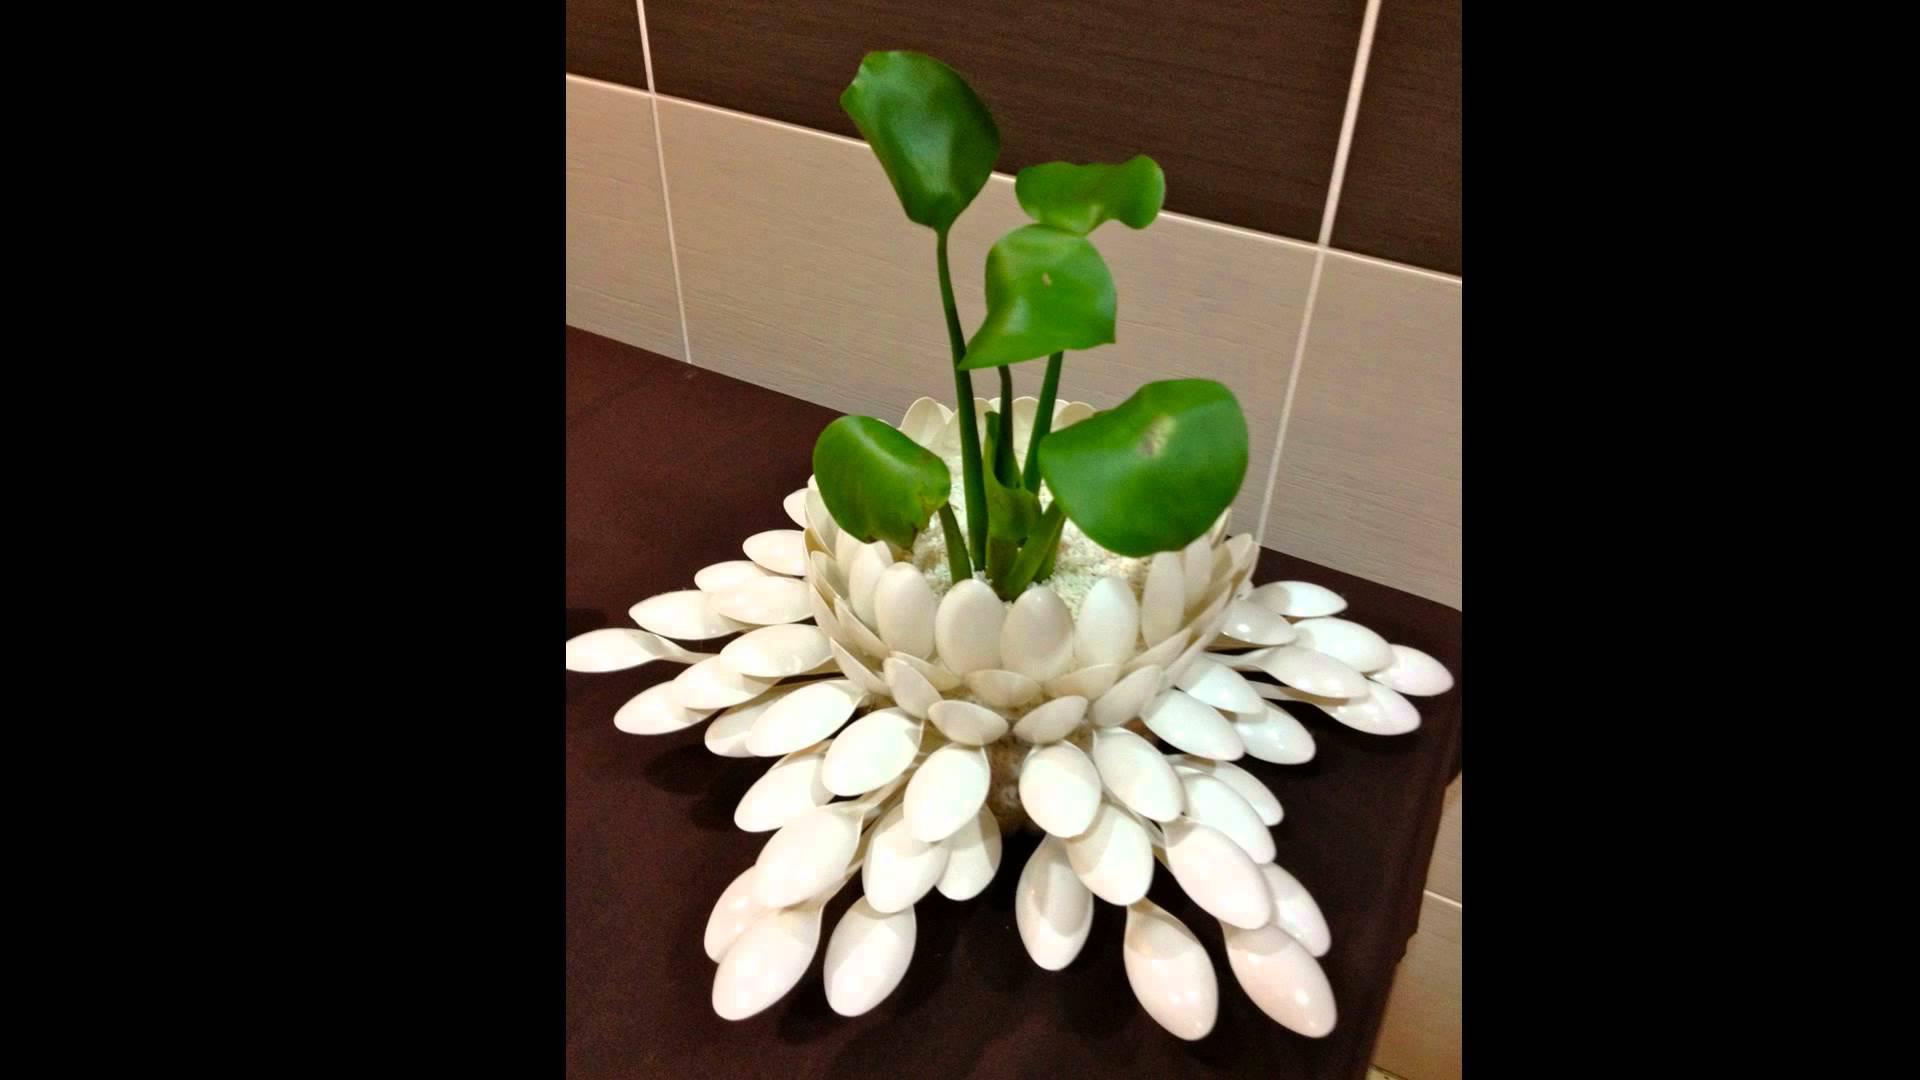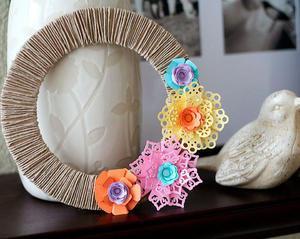The first image is the image on the left, the second image is the image on the right. Given the left and right images, does the statement "One image shows at leat four faux flowers of different colors, and the other image shows a vase made out of stacked layers of oval shapes that are actually plastic spoons." hold true? Answer yes or no. Yes. The first image is the image on the left, the second image is the image on the right. Examine the images to the left and right. Is the description "In one of the images, there are more than one pots with plantlife in them." accurate? Answer yes or no. No. 